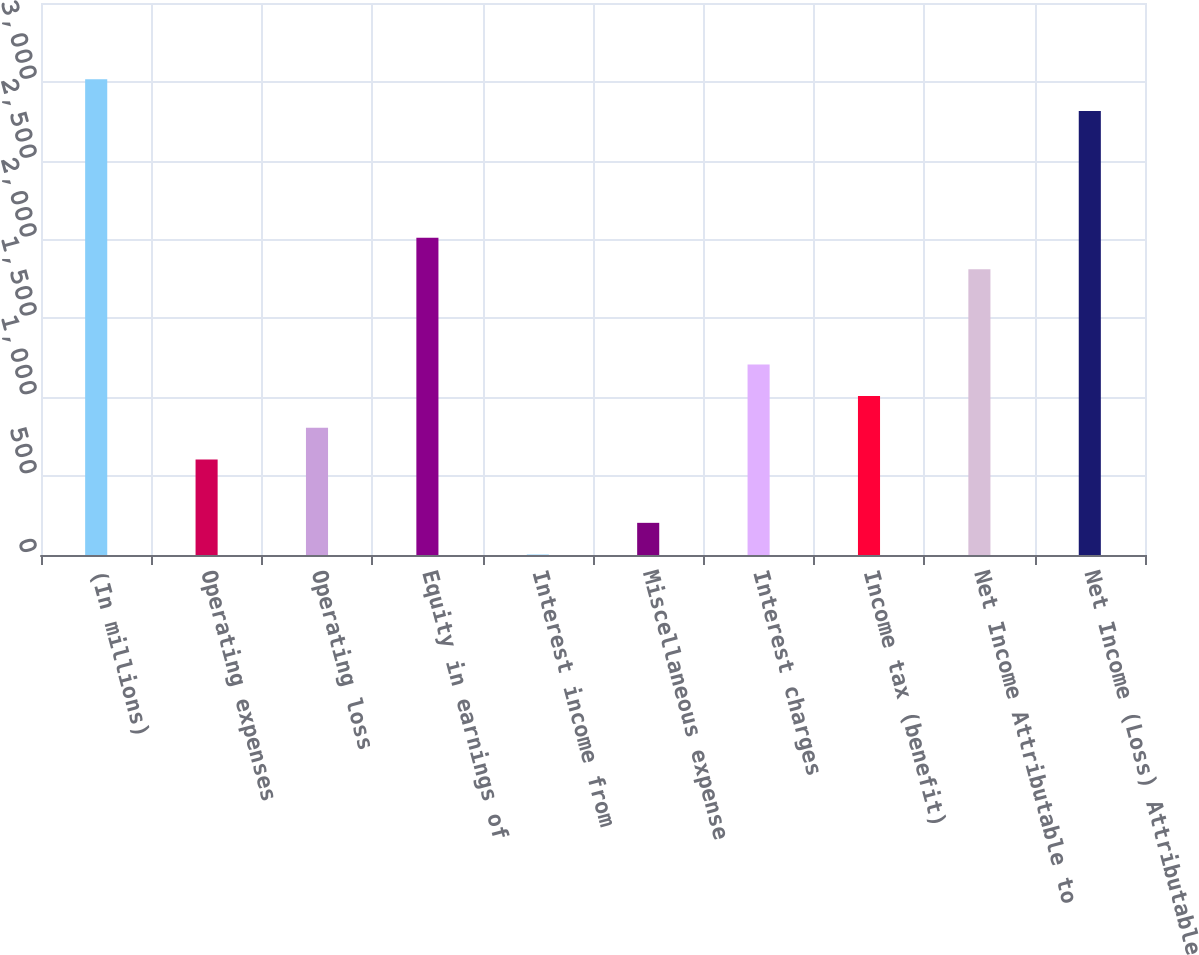Convert chart. <chart><loc_0><loc_0><loc_500><loc_500><bar_chart><fcel>(In millions)<fcel>Operating expenses<fcel>Operating loss<fcel>Equity in earnings of<fcel>Interest income from<fcel>Miscellaneous expense<fcel>Interest charges<fcel>Income tax (benefit)<fcel>Net Income Attributable to<fcel>Net Income (Loss) Attributable<nl><fcel>3016.5<fcel>605.7<fcel>806.6<fcel>2012<fcel>3<fcel>203.9<fcel>1208.4<fcel>1007.5<fcel>1811.1<fcel>2815.6<nl></chart> 